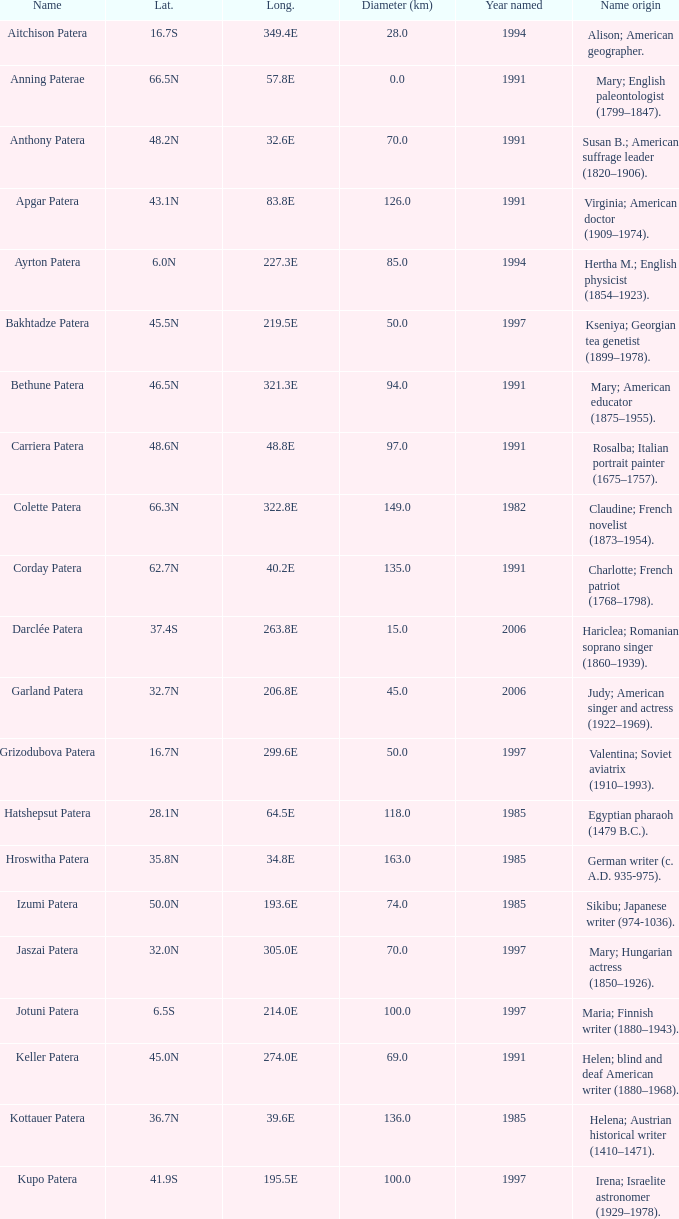In what year was the feature at a 33.3S latitude named?  2000.0. 